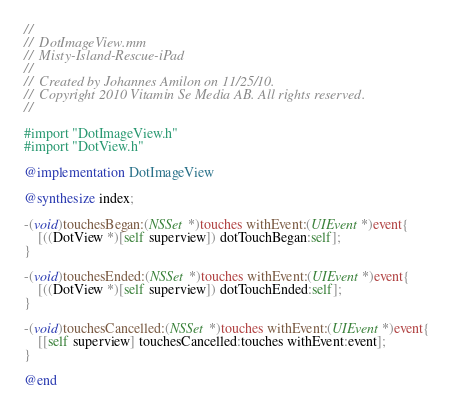<code> <loc_0><loc_0><loc_500><loc_500><_ObjectiveC_>//
//  DotImageView.mm
//  Misty-Island-Rescue-iPad
//
//  Created by Johannes Amilon on 11/25/10.
//  Copyright 2010 Vitamin Se Media AB. All rights reserved.
//

#import "DotImageView.h"
#import "DotView.h"

@implementation DotImageView

@synthesize index;

-(void)touchesBegan:(NSSet *)touches withEvent:(UIEvent *)event{
	[((DotView *)[self superview]) dotTouchBegan:self];
}

-(void)touchesEnded:(NSSet *)touches withEvent:(UIEvent *)event{
	[((DotView *)[self superview]) dotTouchEnded:self];
}

-(void)touchesCancelled:(NSSet *)touches withEvent:(UIEvent *)event{
	[[self superview] touchesCancelled:touches withEvent:event];
}

@end
</code> 